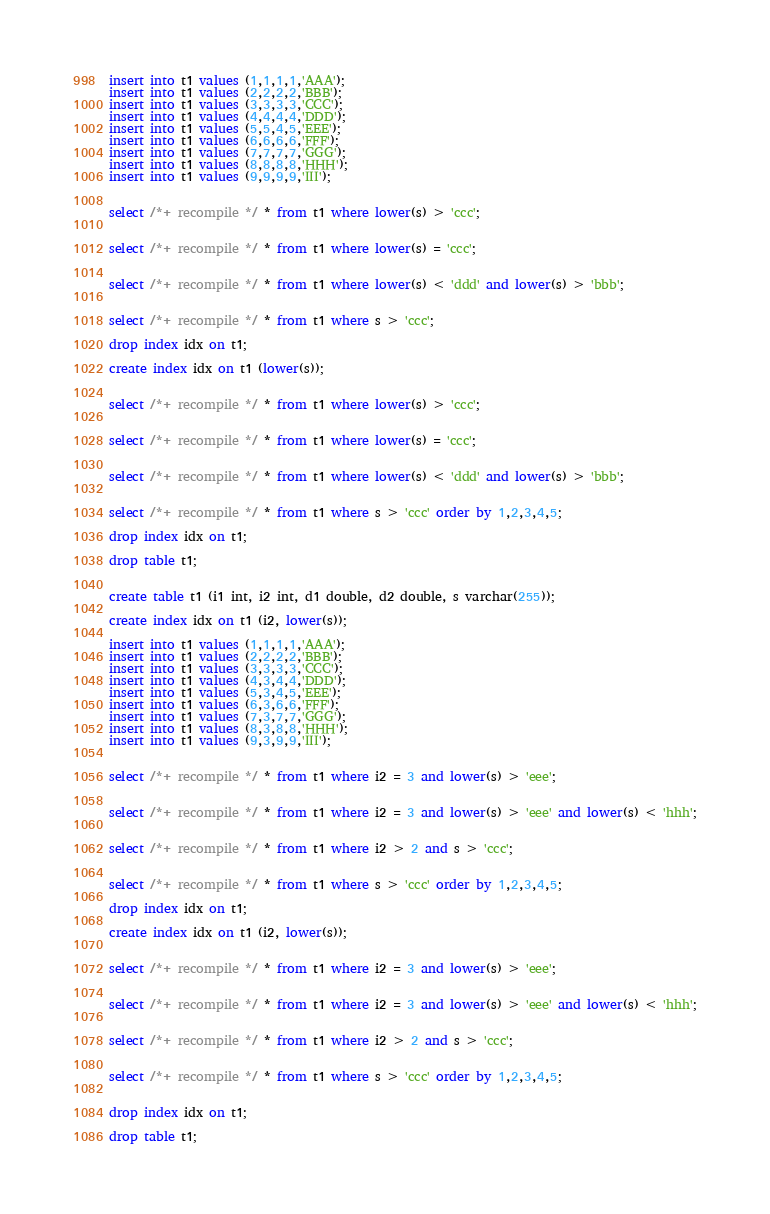Convert code to text. <code><loc_0><loc_0><loc_500><loc_500><_SQL_>insert into t1 values (1,1,1,1,'AAA');
insert into t1 values (2,2,2,2,'BBB');
insert into t1 values (3,3,3,3,'CCC');
insert into t1 values (4,4,4,4,'DDD');
insert into t1 values (5,5,4,5,'EEE');
insert into t1 values (6,6,6,6,'FFF');
insert into t1 values (7,7,7,7,'GGG');
insert into t1 values (8,8,8,8,'HHH');
insert into t1 values (9,9,9,9,'III');


select /*+ recompile */ * from t1 where lower(s) > 'ccc';


select /*+ recompile */ * from t1 where lower(s) = 'ccc';


select /*+ recompile */ * from t1 where lower(s) < 'ddd' and lower(s) > 'bbb';


select /*+ recompile */ * from t1 where s > 'ccc';

drop index idx on t1;

create index idx on t1 (lower(s));


select /*+ recompile */ * from t1 where lower(s) > 'ccc';


select /*+ recompile */ * from t1 where lower(s) = 'ccc';


select /*+ recompile */ * from t1 where lower(s) < 'ddd' and lower(s) > 'bbb';


select /*+ recompile */ * from t1 where s > 'ccc' order by 1,2,3,4,5;

drop index idx on t1;

drop table t1;


create table t1 (i1 int, i2 int, d1 double, d2 double, s varchar(255));

create index idx on t1 (i2, lower(s));

insert into t1 values (1,1,1,1,'AAA');
insert into t1 values (2,2,2,2,'BBB');
insert into t1 values (3,3,3,3,'CCC');
insert into t1 values (4,3,4,4,'DDD');
insert into t1 values (5,3,4,5,'EEE');
insert into t1 values (6,3,6,6,'FFF');
insert into t1 values (7,3,7,7,'GGG');
insert into t1 values (8,3,8,8,'HHH');
insert into t1 values (9,3,9,9,'III');


select /*+ recompile */ * from t1 where i2 = 3 and lower(s) > 'eee';


select /*+ recompile */ * from t1 where i2 = 3 and lower(s) > 'eee' and lower(s) < 'hhh';


select /*+ recompile */ * from t1 where i2 > 2 and s > 'ccc';


select /*+ recompile */ * from t1 where s > 'ccc' order by 1,2,3,4,5;

drop index idx on t1;

create index idx on t1 (i2, lower(s));


select /*+ recompile */ * from t1 where i2 = 3 and lower(s) > 'eee';


select /*+ recompile */ * from t1 where i2 = 3 and lower(s) > 'eee' and lower(s) < 'hhh';


select /*+ recompile */ * from t1 where i2 > 2 and s > 'ccc';


select /*+ recompile */ * from t1 where s > 'ccc' order by 1,2,3,4,5;


drop index idx on t1;

drop table t1;

</code> 